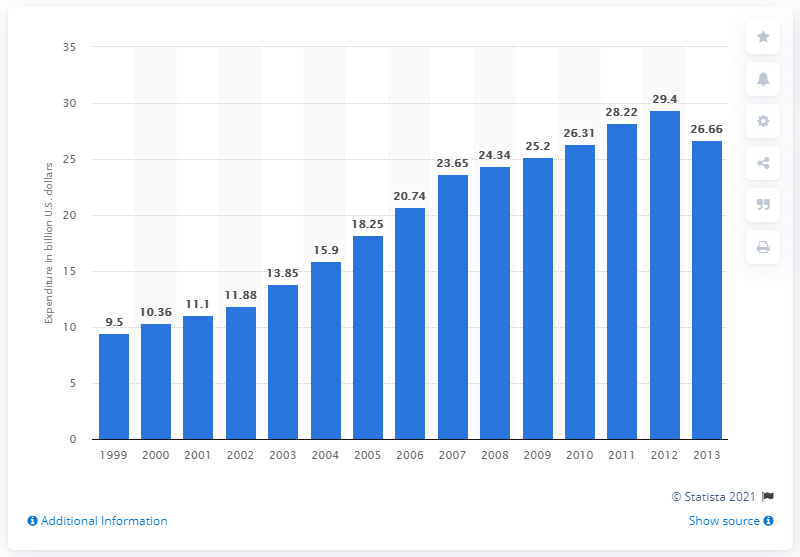Give some essential details in this illustration. In 2013, the consumer expenditure on live entertainment in the United States was 26.66 dollars. 